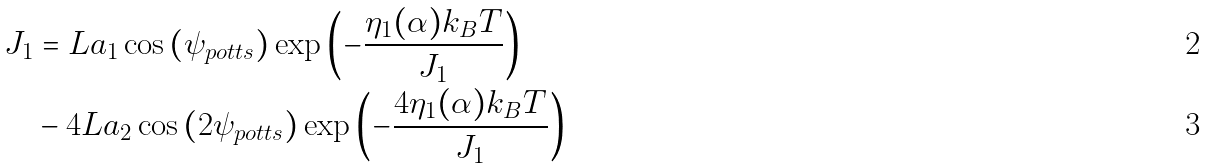Convert formula to latex. <formula><loc_0><loc_0><loc_500><loc_500>J _ { 1 } & = L a _ { 1 } \cos \left ( { \psi _ { p o t t s } } \right ) \exp \left ( { - \frac { \eta _ { 1 } ( \alpha ) k _ { B } T } { J _ { 1 } } } \right ) \\ & - 4 L a _ { 2 } \cos \left ( { 2 \psi _ { p o t t s } } \right ) \exp \left ( { - \frac { 4 \eta _ { 1 } ( \alpha ) k _ { B } T } { J _ { 1 } } } \right )</formula> 